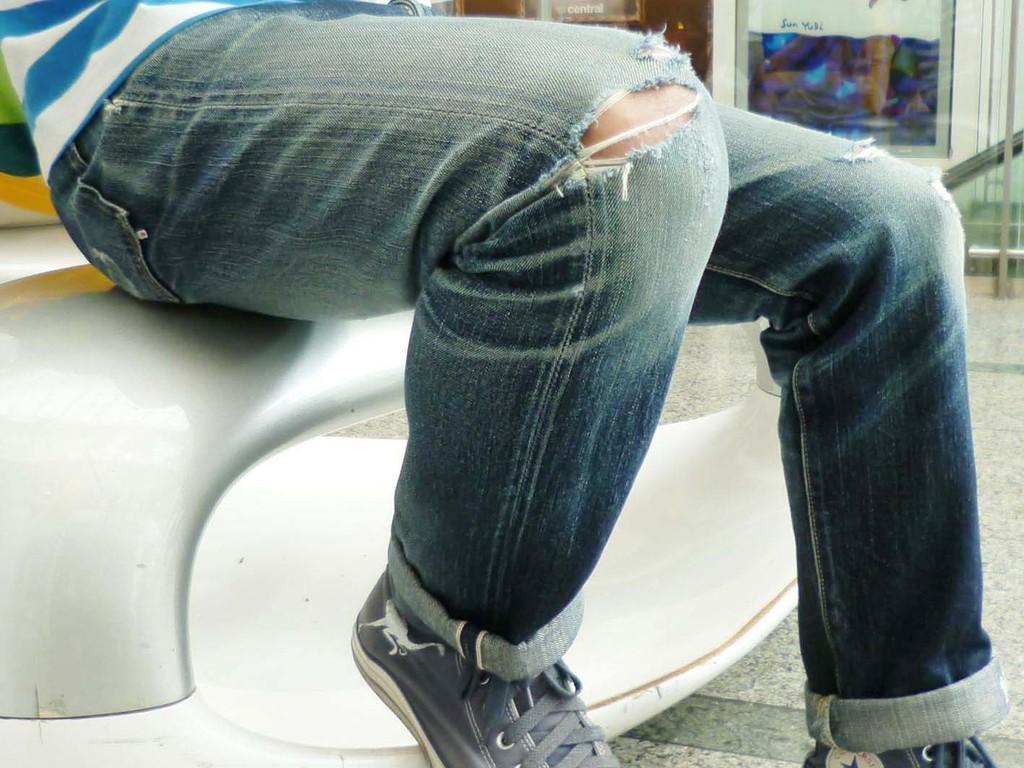Could you give a brief overview of what you see in this image? In the image,only the legs of a man are visible and the man wore torn jeans and shoes,there are some showrooms behind the man. 